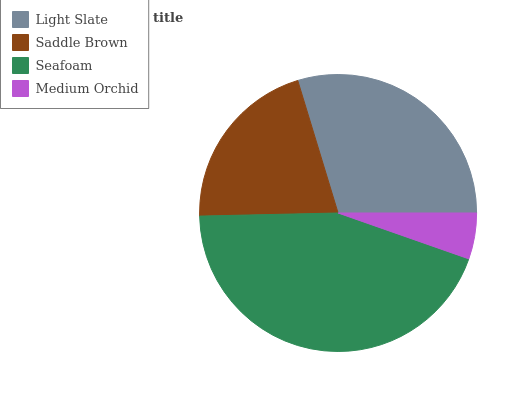Is Medium Orchid the minimum?
Answer yes or no. Yes. Is Seafoam the maximum?
Answer yes or no. Yes. Is Saddle Brown the minimum?
Answer yes or no. No. Is Saddle Brown the maximum?
Answer yes or no. No. Is Light Slate greater than Saddle Brown?
Answer yes or no. Yes. Is Saddle Brown less than Light Slate?
Answer yes or no. Yes. Is Saddle Brown greater than Light Slate?
Answer yes or no. No. Is Light Slate less than Saddle Brown?
Answer yes or no. No. Is Light Slate the high median?
Answer yes or no. Yes. Is Saddle Brown the low median?
Answer yes or no. Yes. Is Seafoam the high median?
Answer yes or no. No. Is Seafoam the low median?
Answer yes or no. No. 